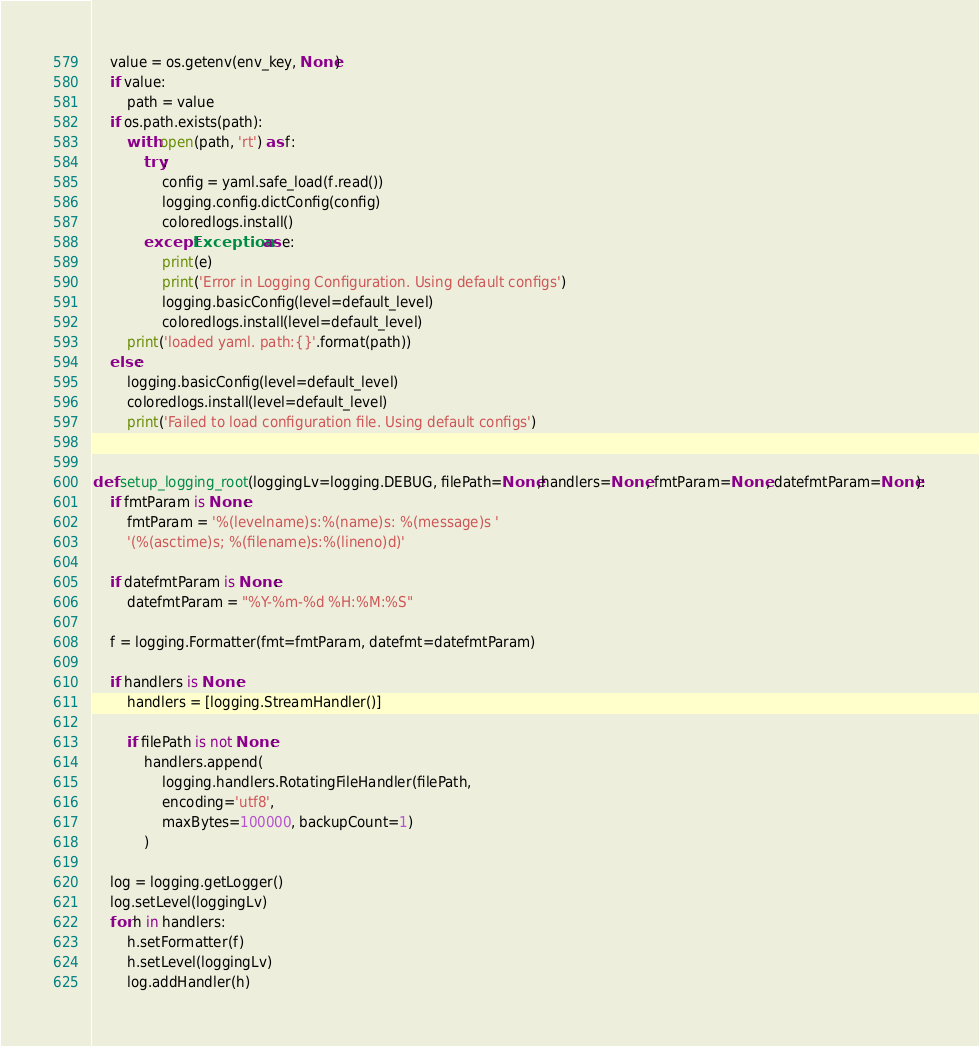<code> <loc_0><loc_0><loc_500><loc_500><_Python_>    value = os.getenv(env_key, None)
    if value:
        path = value
    if os.path.exists(path):
        with open(path, 'rt') as f:
            try:
                config = yaml.safe_load(f.read())
                logging.config.dictConfig(config)
                coloredlogs.install()
            except Exception as e:
                print(e)
                print('Error in Logging Configuration. Using default configs')
                logging.basicConfig(level=default_level)
                coloredlogs.install(level=default_level)
        print('loaded yaml. path:{}'.format(path))
    else:
        logging.basicConfig(level=default_level)
        coloredlogs.install(level=default_level)
        print('Failed to load configuration file. Using default configs')


def setup_logging_root(loggingLv=logging.DEBUG, filePath=None,handlers=None, fmtParam=None, datefmtParam=None):
    if fmtParam is None:
        fmtParam = '%(levelname)s:%(name)s: %(message)s '
        '(%(asctime)s; %(filename)s:%(lineno)d)'

    if datefmtParam is None:
        datefmtParam = "%Y-%m-%d %H:%M:%S"

    f = logging.Formatter(fmt=fmtParam, datefmt=datefmtParam)

    if handlers is None:
        handlers = [logging.StreamHandler()]

        if filePath is not None:
            handlers.append(
                logging.handlers.RotatingFileHandler(filePath, 
                encoding='utf8',
                maxBytes=100000, backupCount=1)
            )

    log = logging.getLogger()
    log.setLevel(loggingLv)
    for h in handlers:
        h.setFormatter(f)
        h.setLevel(loggingLv)
        log.addHandler(h)</code> 